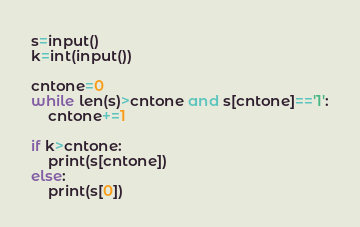<code> <loc_0><loc_0><loc_500><loc_500><_Python_>s=input()
k=int(input())

cntone=0
while len(s)>cntone and s[cntone]=='1':
    cntone+=1

if k>cntone:
    print(s[cntone])
else:
    print(s[0])
</code> 